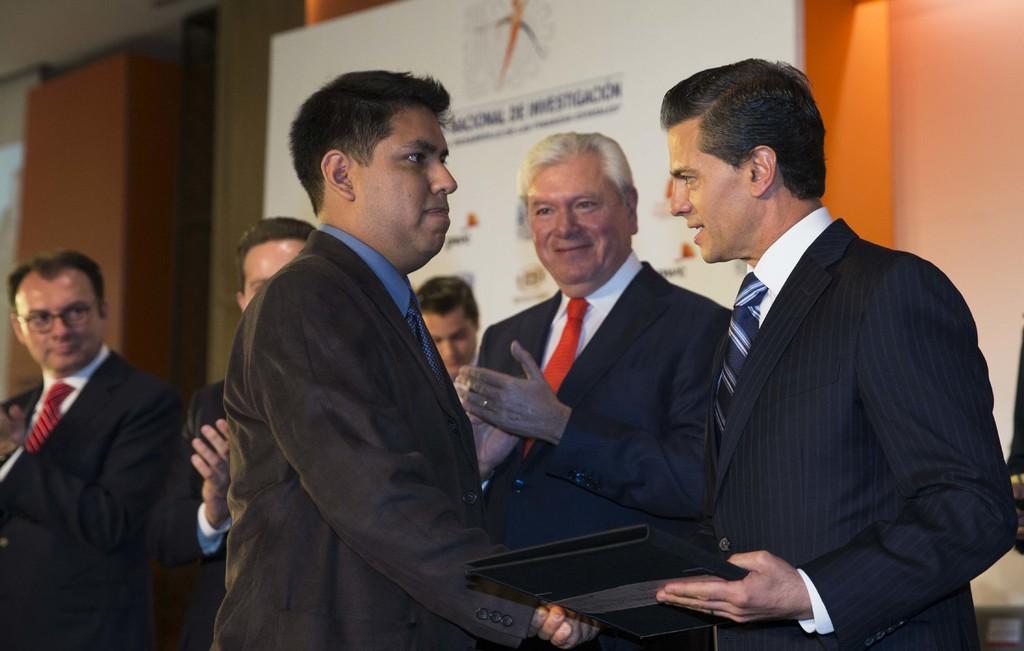Can you describe this image briefly? In this picture we can see a man holding an object in his hand. We can see a few people. There is some text and a few things on a board. We can see other objects. 